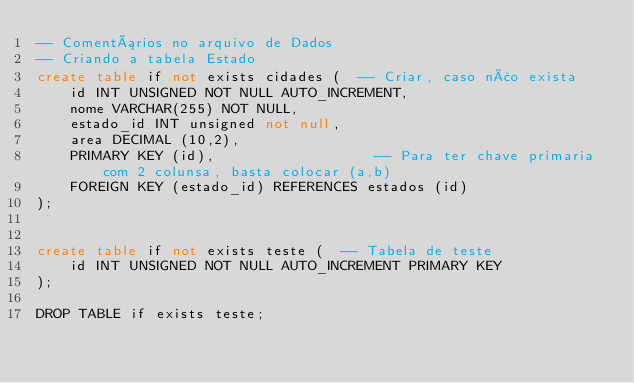<code> <loc_0><loc_0><loc_500><loc_500><_SQL_>-- Comentários no arquivo de Dados
-- Criando a tabela Estado 
create table if not exists cidades (  -- Criar, caso não exista
    id INT UNSIGNED NOT NULL AUTO_INCREMENT,
    nome VARCHAR(255) NOT NULL,
    estado_id INT unsigned not null,
    area DECIMAL (10,2),
    PRIMARY KEY (id),                   -- Para ter chave primaria com 2 colunsa, basta colocar (a,b)
    FOREIGN KEY (estado_id) REFERENCES estados (id)
);


create table if not exists teste (  -- Tabela de teste 
    id INT UNSIGNED NOT NULL AUTO_INCREMENT PRIMARY KEY
);

DROP TABLE if exists teste;</code> 